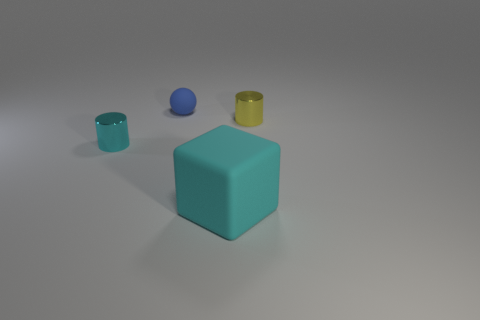Add 1 large purple blocks. How many objects exist? 5 Subtract all spheres. How many objects are left? 3 Add 1 small cyan cylinders. How many small cyan cylinders are left? 2 Add 4 large brown metal cylinders. How many large brown metal cylinders exist? 4 Subtract 0 yellow balls. How many objects are left? 4 Subtract all rubber things. Subtract all big cyan rubber things. How many objects are left? 1 